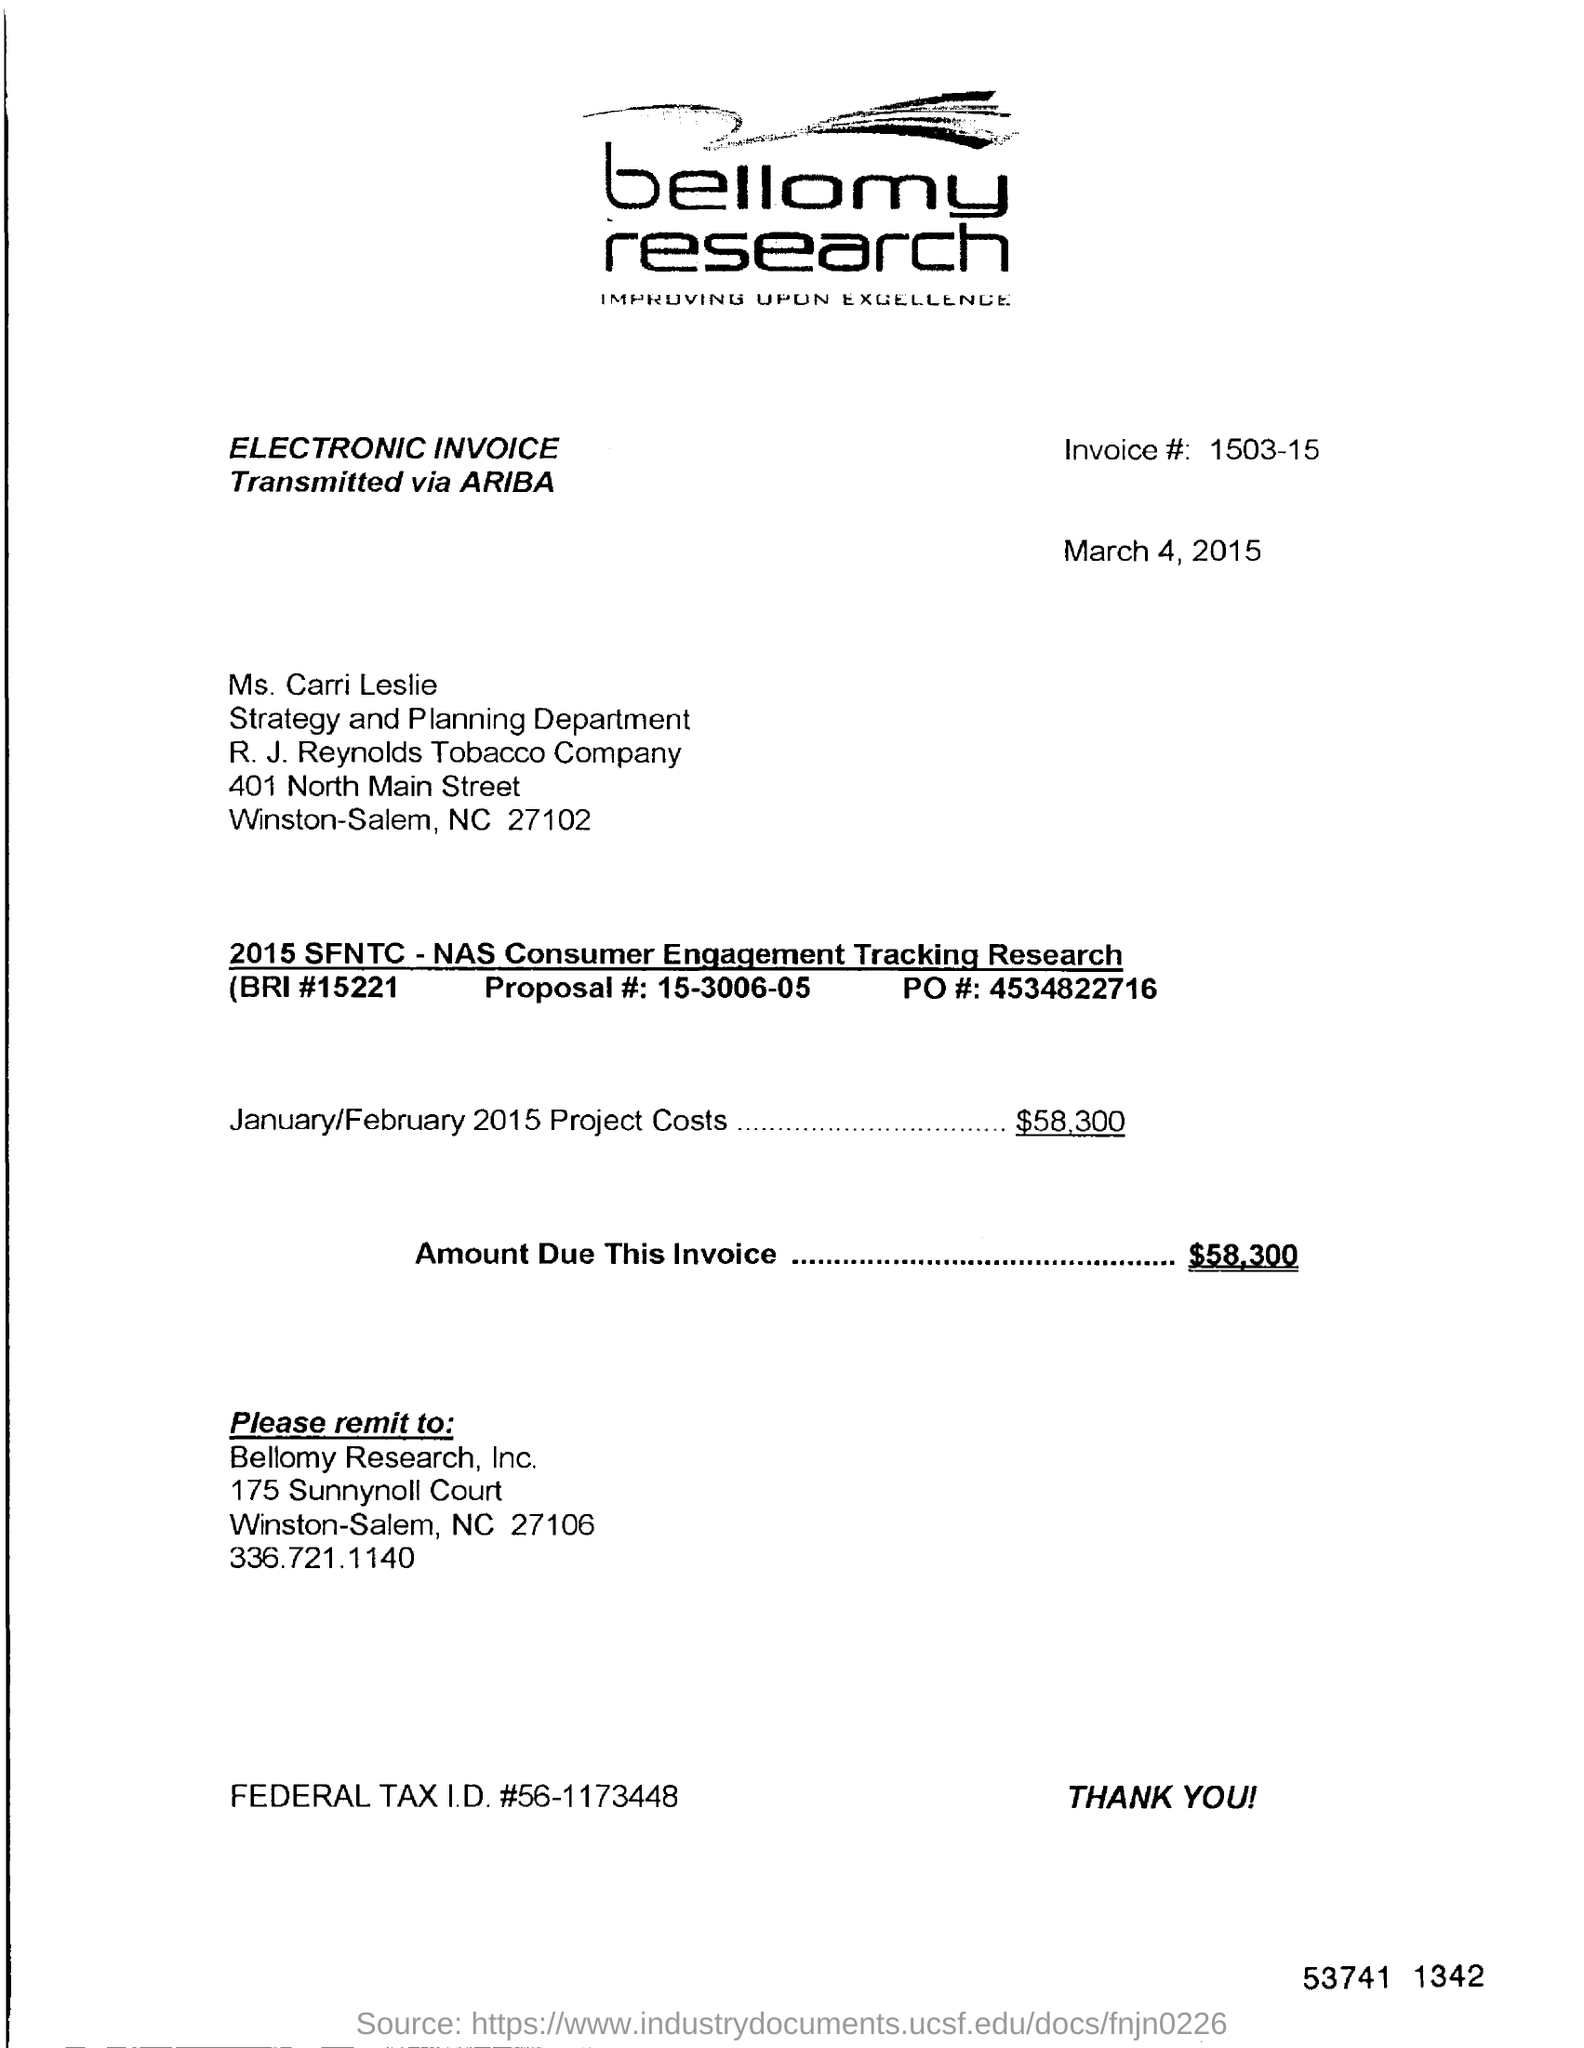What is the project cost for the month of january/february2015?
Ensure brevity in your answer.  $58,300. What is the name of the company ?
Your response must be concise. Bellomy Research, Inc. What is the invoice code ?
Give a very brief answer. 1503-15. Which department is mentioned in the invoice ?
Your response must be concise. Strategy and Planning. 